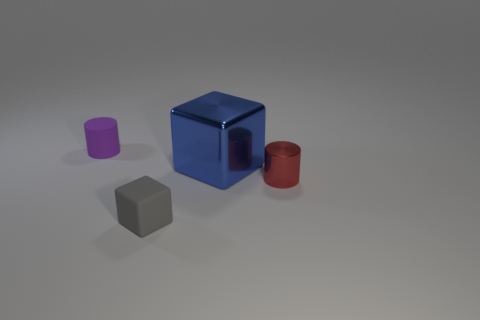There is a gray thing that is the same size as the purple cylinder; what material is it?
Ensure brevity in your answer.  Rubber. How many other objects are there of the same material as the tiny purple cylinder?
Give a very brief answer. 1. Does the small rubber object right of the purple rubber cylinder have the same shape as the tiny thing right of the large thing?
Give a very brief answer. No. What number of other objects are the same color as the rubber cylinder?
Your response must be concise. 0. Do the cylinder to the right of the rubber cylinder and the block behind the small red cylinder have the same material?
Provide a succinct answer. Yes. Are there the same number of red metal cylinders that are left of the matte block and red metallic things right of the purple object?
Ensure brevity in your answer.  No. There is a tiny cylinder in front of the big blue shiny thing; what is it made of?
Give a very brief answer. Metal. Is there any other thing that is the same size as the blue metal cube?
Your response must be concise. No. Are there fewer matte things than metal cylinders?
Provide a succinct answer. No. There is a thing that is both behind the red cylinder and on the right side of the small gray cube; what shape is it?
Provide a succinct answer. Cube. 